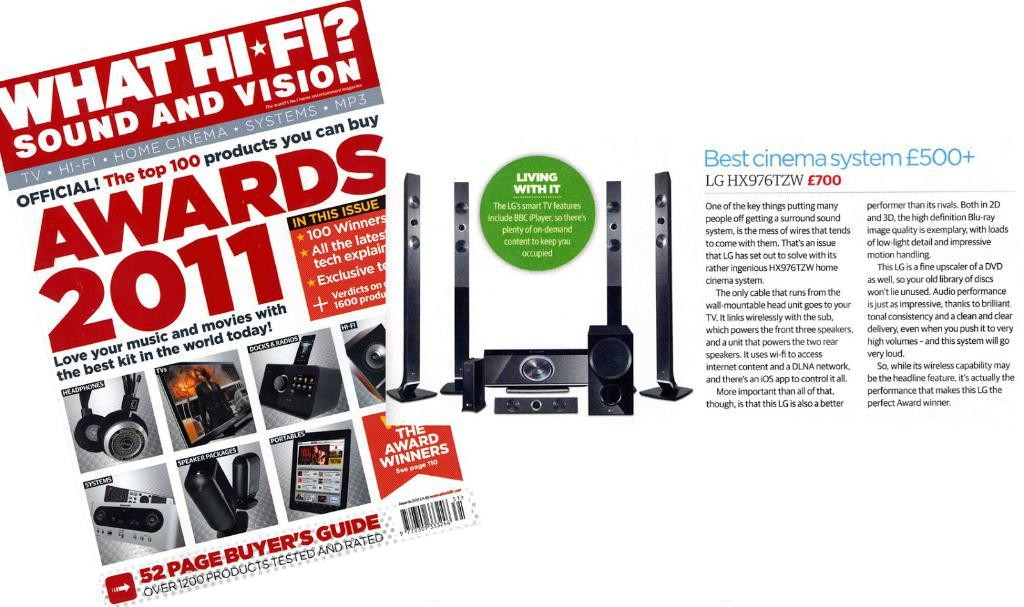<image>
Summarize the visual content of the image. A magazine cover with Awards 2011 on it and an article about the best cinema system next to it. 